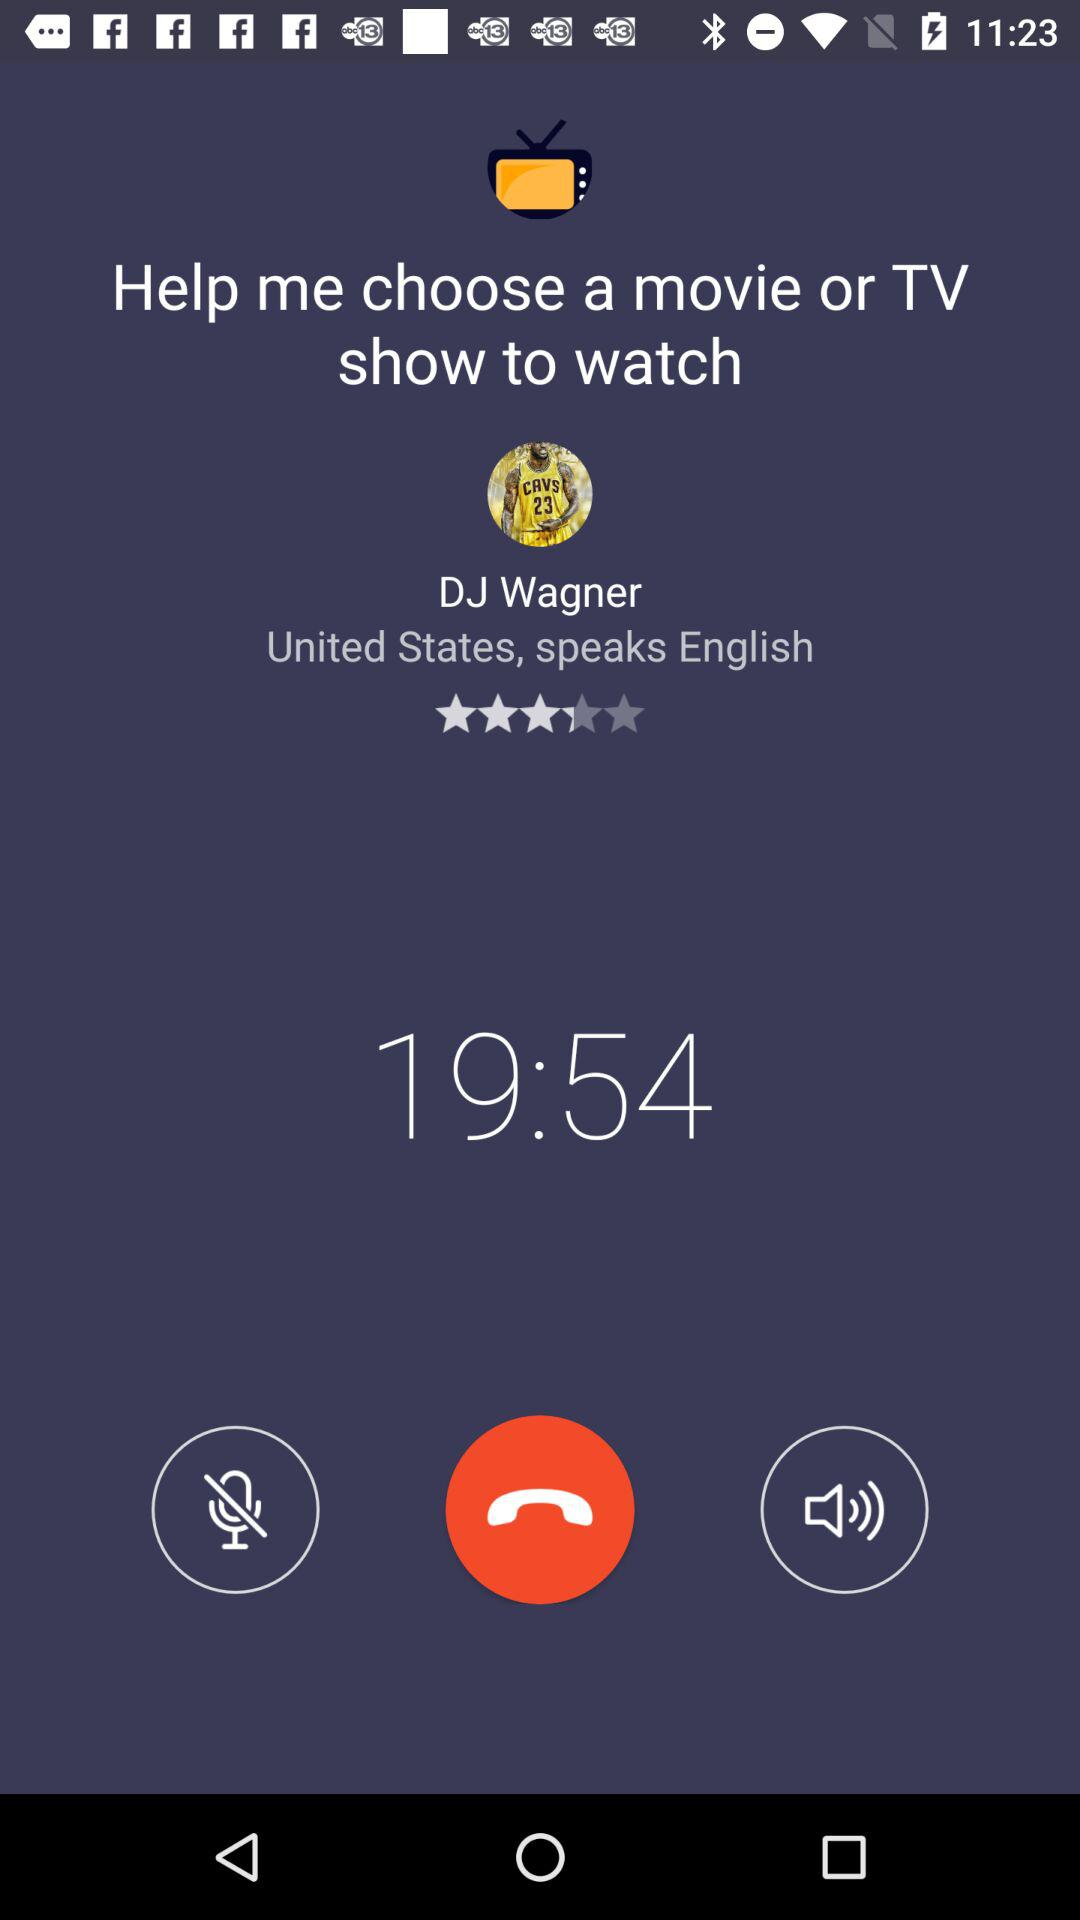Which movie is DJ Wagner going to watch?
When the provided information is insufficient, respond with <no answer>. <no answer> 